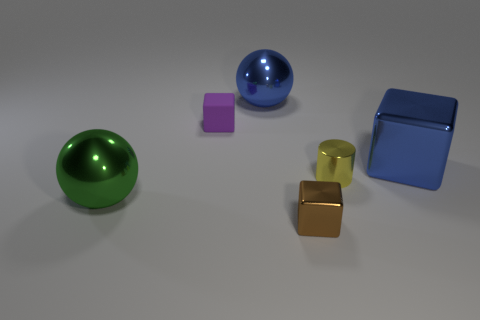Add 2 purple matte things. How many objects exist? 8 Subtract all cylinders. How many objects are left? 5 Add 3 large green metal objects. How many large green metal objects are left? 4 Add 1 yellow cylinders. How many yellow cylinders exist? 2 Subtract 1 brown blocks. How many objects are left? 5 Subtract all big green balls. Subtract all large metal things. How many objects are left? 2 